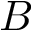Convert formula to latex. <formula><loc_0><loc_0><loc_500><loc_500>B</formula> 